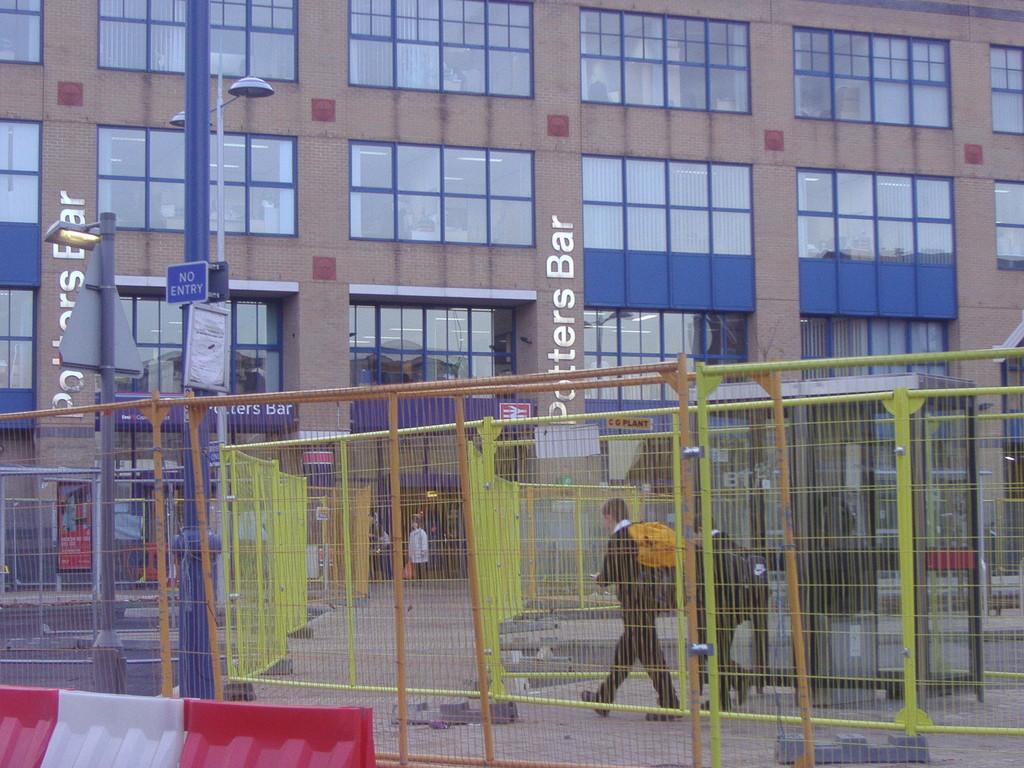Describe this image in one or two sentences. In the picture I can see a person walking and there is a fence on either sides of him and there is a building,pole and some other objects in the background. 